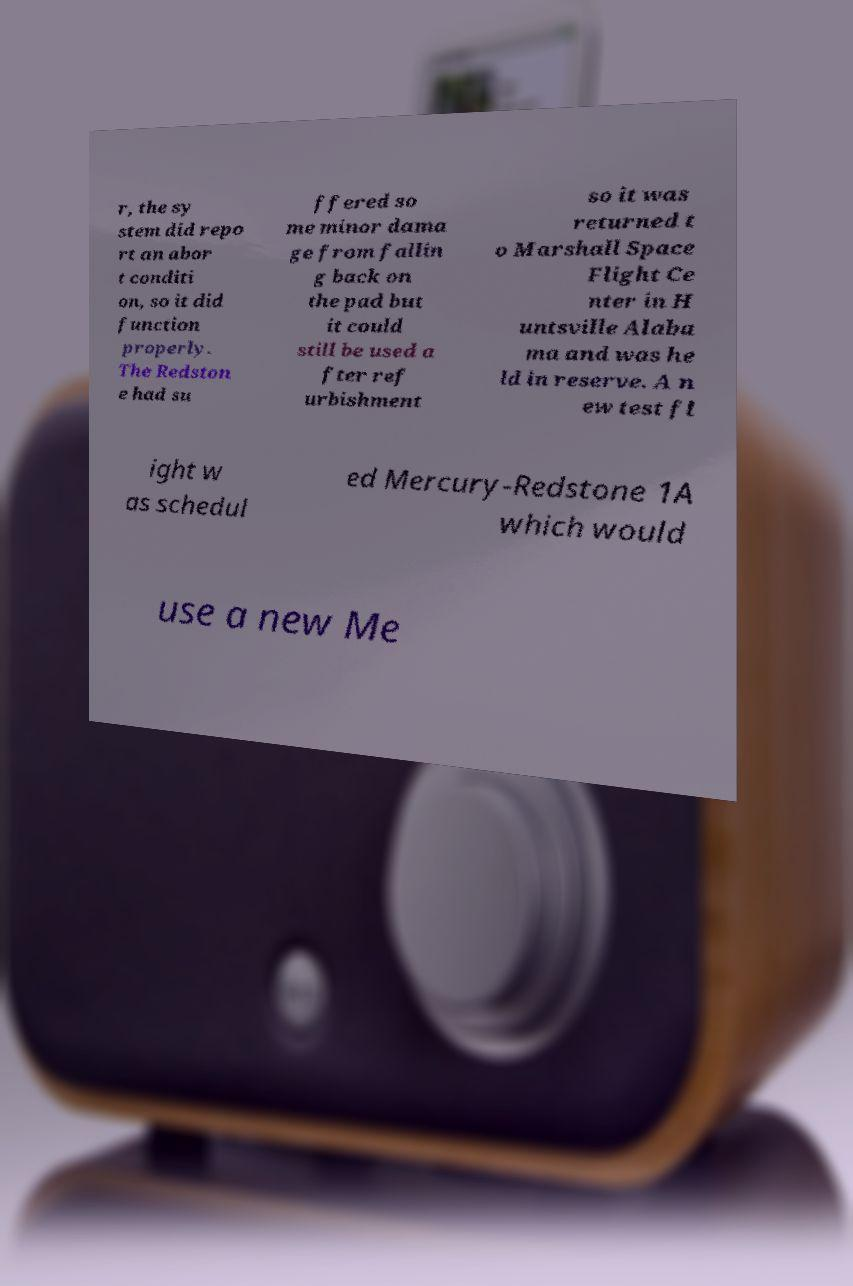Can you read and provide the text displayed in the image?This photo seems to have some interesting text. Can you extract and type it out for me? r, the sy stem did repo rt an abor t conditi on, so it did function properly. The Redston e had su ffered so me minor dama ge from fallin g back on the pad but it could still be used a fter ref urbishment so it was returned t o Marshall Space Flight Ce nter in H untsville Alaba ma and was he ld in reserve. A n ew test fl ight w as schedul ed Mercury-Redstone 1A which would use a new Me 